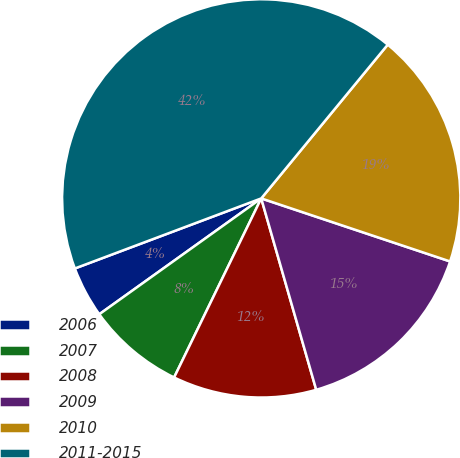Convert chart. <chart><loc_0><loc_0><loc_500><loc_500><pie_chart><fcel>2006<fcel>2007<fcel>2008<fcel>2009<fcel>2010<fcel>2011-2015<nl><fcel>4.16%<fcel>7.91%<fcel>11.66%<fcel>15.42%<fcel>19.17%<fcel>41.68%<nl></chart> 